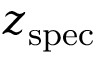<formula> <loc_0><loc_0><loc_500><loc_500>z _ { s p e c }</formula> 